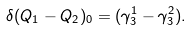<formula> <loc_0><loc_0><loc_500><loc_500>\delta ( Q _ { 1 } - Q _ { 2 } ) _ { 0 } = ( \gamma _ { 3 } ^ { 1 } - \gamma _ { 3 } ^ { 2 } ) .</formula> 